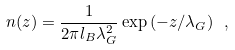<formula> <loc_0><loc_0><loc_500><loc_500>n ( z ) = \frac { 1 } { 2 \pi l _ { B } \lambda _ { G } ^ { 2 } } \exp { ( - z / \lambda _ { G } ) } \ ,</formula> 